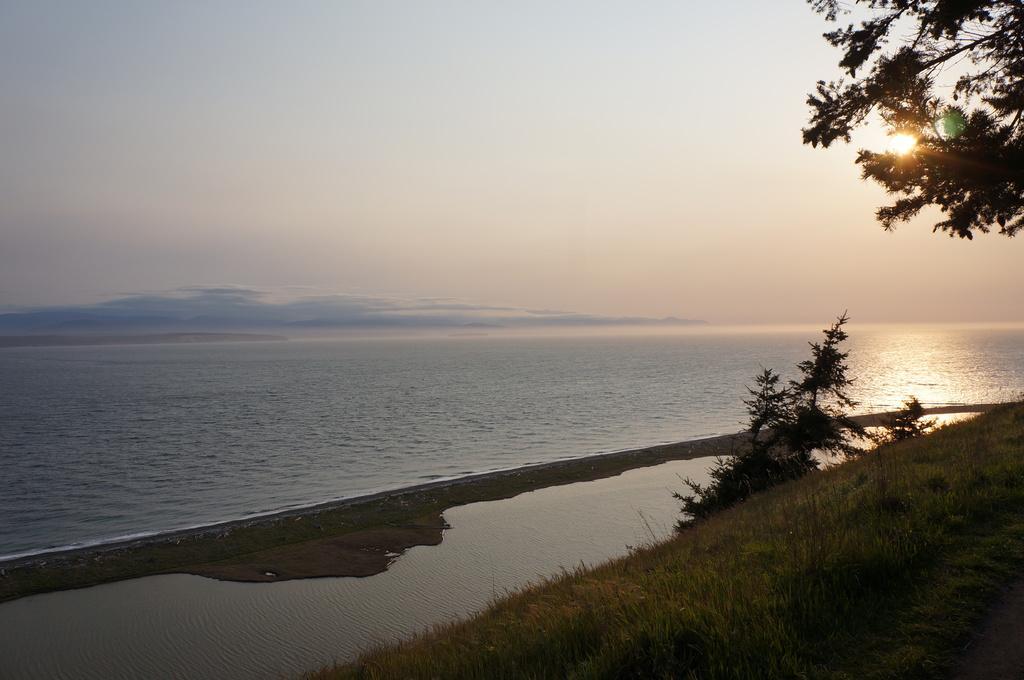Please provide a concise description of this image. This image consists of water in the middle. There are trees on the right side. There is sun on the right side. There is sky at the top. 